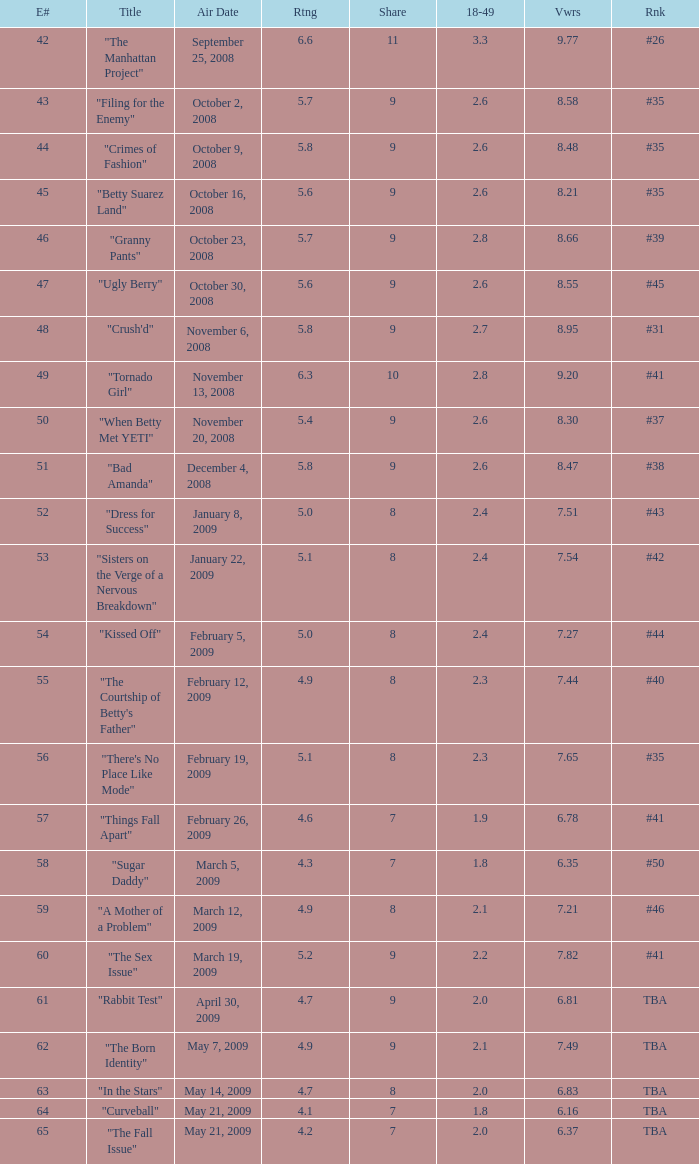What is the average Episode # with a 7 share and 18–49 is less than 2 and the Air Date of may 21, 2009? 64.0. 